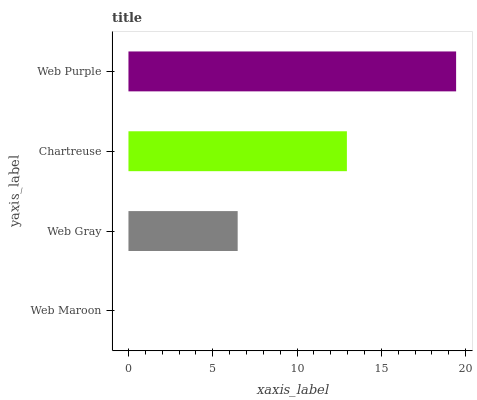Is Web Maroon the minimum?
Answer yes or no. Yes. Is Web Purple the maximum?
Answer yes or no. Yes. Is Web Gray the minimum?
Answer yes or no. No. Is Web Gray the maximum?
Answer yes or no. No. Is Web Gray greater than Web Maroon?
Answer yes or no. Yes. Is Web Maroon less than Web Gray?
Answer yes or no. Yes. Is Web Maroon greater than Web Gray?
Answer yes or no. No. Is Web Gray less than Web Maroon?
Answer yes or no. No. Is Chartreuse the high median?
Answer yes or no. Yes. Is Web Gray the low median?
Answer yes or no. Yes. Is Web Purple the high median?
Answer yes or no. No. Is Web Purple the low median?
Answer yes or no. No. 